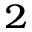Convert formula to latex. <formula><loc_0><loc_0><loc_500><loc_500>^ { 2 }</formula> 